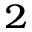Convert formula to latex. <formula><loc_0><loc_0><loc_500><loc_500>^ { 2 }</formula> 